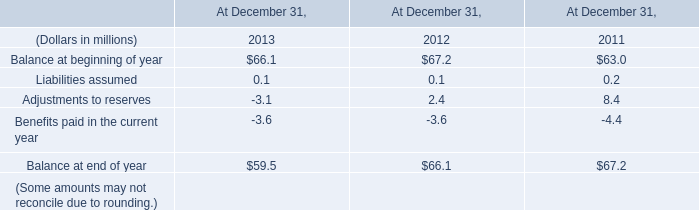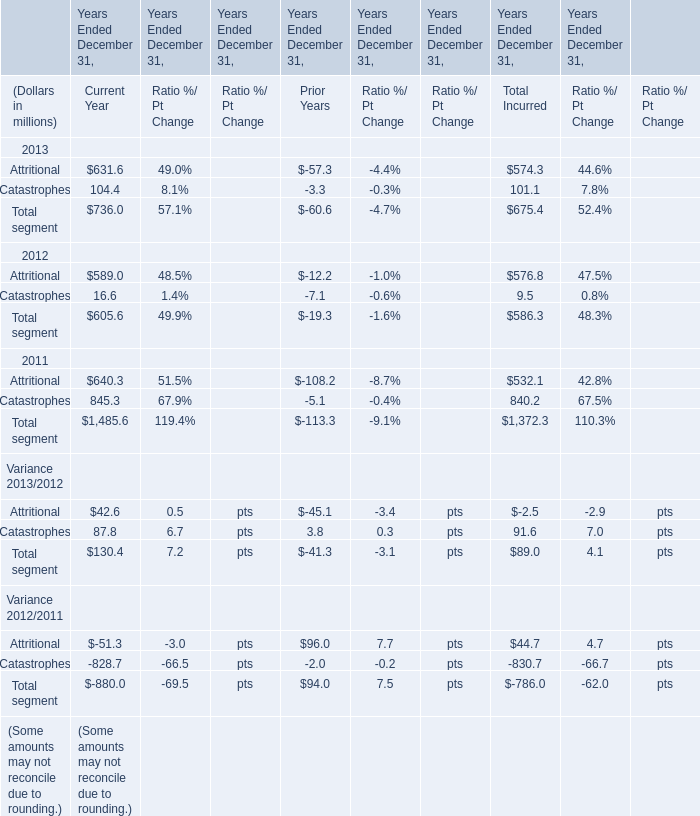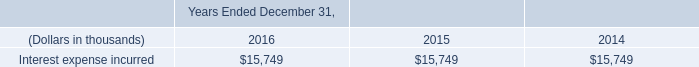As As the chart 1 shows,which Year(Ended December 31,which Year) is the value for Attritional for Total Incurred the lowest? 
Answer: 2011. 